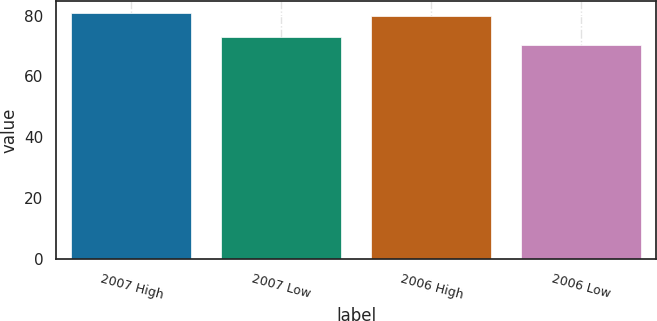Convert chart. <chart><loc_0><loc_0><loc_500><loc_500><bar_chart><fcel>2007 High<fcel>2007 Low<fcel>2006 High<fcel>2006 Low<nl><fcel>80.79<fcel>72.9<fcel>79.83<fcel>70.3<nl></chart> 